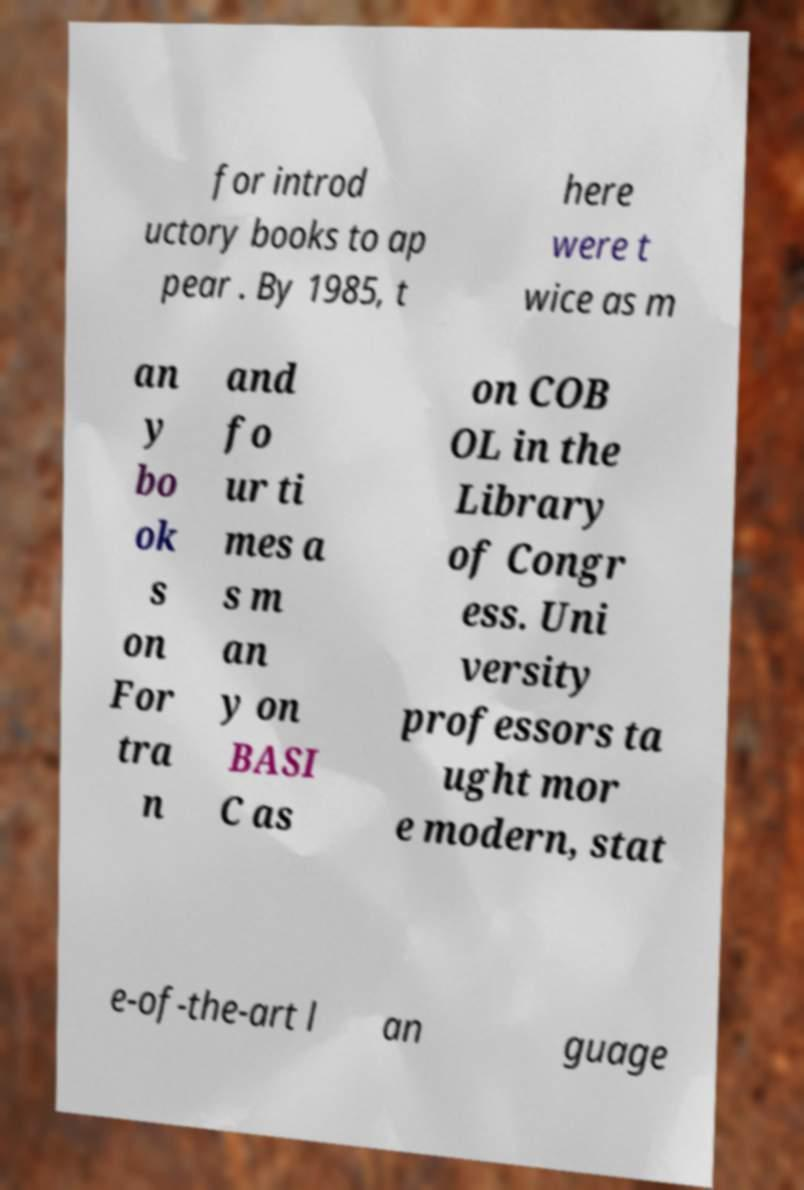What messages or text are displayed in this image? I need them in a readable, typed format. for introd uctory books to ap pear . By 1985, t here were t wice as m an y bo ok s on For tra n and fo ur ti mes a s m an y on BASI C as on COB OL in the Library of Congr ess. Uni versity professors ta ught mor e modern, stat e-of-the-art l an guage 